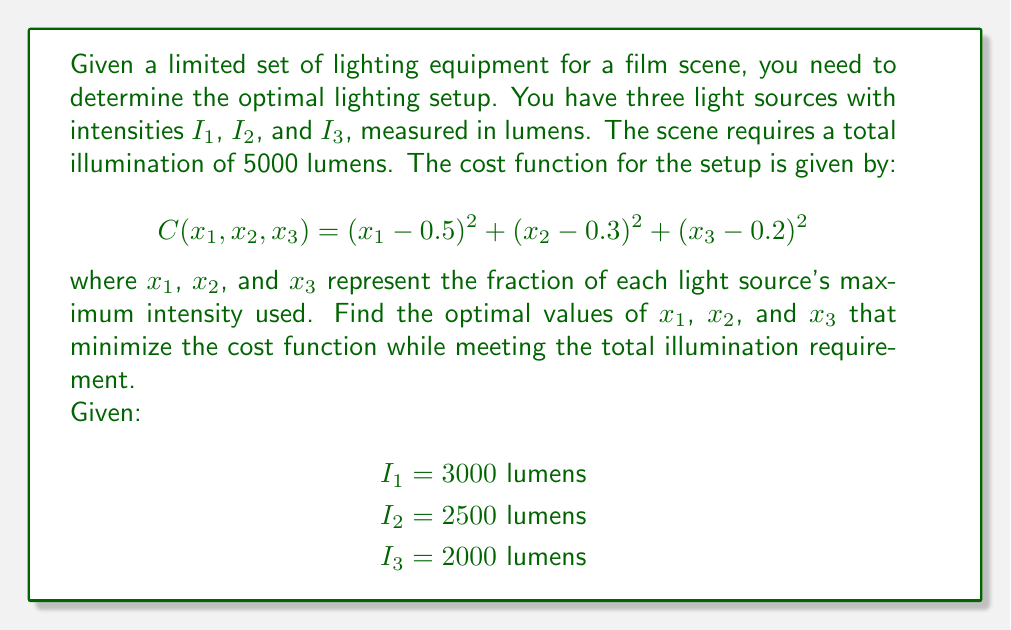Show me your answer to this math problem. To solve this inverse problem, we'll use the method of Lagrange multipliers:

1) First, we set up the constraint equation:
   $$g(x_1, x_2, x_3) = 3000x_1 + 2500x_2 + 2000x_3 - 5000 = 0$$

2) Now, we form the Lagrangian function:
   $$L(x_1, x_2, x_3, \lambda) = (x_1 - 0.5)^2 + (x_2 - 0.3)^2 + (x_3 - 0.2)^2 + \lambda(3000x_1 + 2500x_2 + 2000x_3 - 5000)$$

3) We take partial derivatives and set them to zero:
   $$\frac{\partial L}{\partial x_1} = 2(x_1 - 0.5) + 3000\lambda = 0$$
   $$\frac{\partial L}{\partial x_2} = 2(x_2 - 0.3) + 2500\lambda = 0$$
   $$\frac{\partial L}{\partial x_3} = 2(x_3 - 0.2) + 2000\lambda = 0$$
   $$\frac{\partial L}{\partial \lambda} = 3000x_1 + 2500x_2 + 2000x_3 - 5000 = 0$$

4) From the first three equations:
   $$x_1 = 0.5 - 1500\lambda$$
   $$x_2 = 0.3 - 1250\lambda$$
   $$x_3 = 0.2 - 1000\lambda$$

5) Substitute these into the fourth equation:
   $$3000(0.5 - 1500\lambda) + 2500(0.3 - 1250\lambda) + 2000(0.2 - 1000\lambda) = 5000$$
   $$1500 + 750 + 400 - 4500000\lambda - 3125000\lambda - 2000000\lambda = 5000$$
   $$2650 - 9625000\lambda = 5000$$
   $$-9625000\lambda = 2350$$
   $$\lambda = -0.000244$$

6) Now we can solve for $x_1$, $x_2$, and $x_3$:
   $$x_1 = 0.5 - 1500(-0.000244) = 0.866$$
   $$x_2 = 0.3 - 1250(-0.000244) = 0.605$$
   $$x_3 = 0.2 - 1000(-0.000244) = 0.444$$
Answer: $x_1 = 0.866$, $x_2 = 0.605$, $x_3 = 0.444$ 